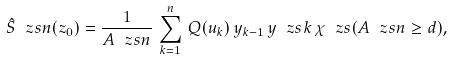Convert formula to latex. <formula><loc_0><loc_0><loc_500><loc_500>\hat { S } _ { \ } z s { n } ( z _ { 0 } ) = \frac { 1 } { A _ { \ } z s { n } } \, \sum ^ { n } _ { k = 1 } \, Q ( u _ { k } ) \, y _ { k - 1 } \, y _ { \ } z s { k } \, \chi _ { \ } z s { ( A _ { \ } z s { n } \geq d ) } ,</formula> 